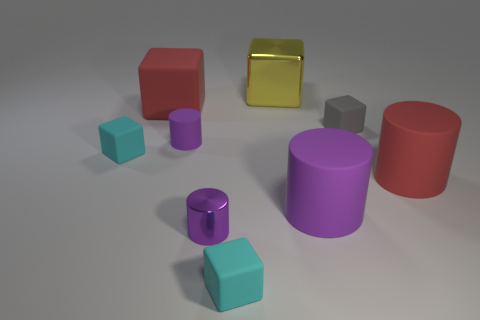How many purple cylinders must be subtracted to get 1 purple cylinders? 2 Subtract all big red rubber cylinders. How many cylinders are left? 3 Subtract all yellow blocks. How many blocks are left? 4 Subtract 4 cylinders. How many cylinders are left? 0 Subtract all cubes. How many objects are left? 4 Subtract all blue balls. How many purple cubes are left? 0 Add 6 cyan objects. How many cyan objects exist? 8 Subtract 0 brown cylinders. How many objects are left? 9 Subtract all purple cylinders. Subtract all cyan balls. How many cylinders are left? 1 Subtract all big green metal spheres. Subtract all purple cylinders. How many objects are left? 6 